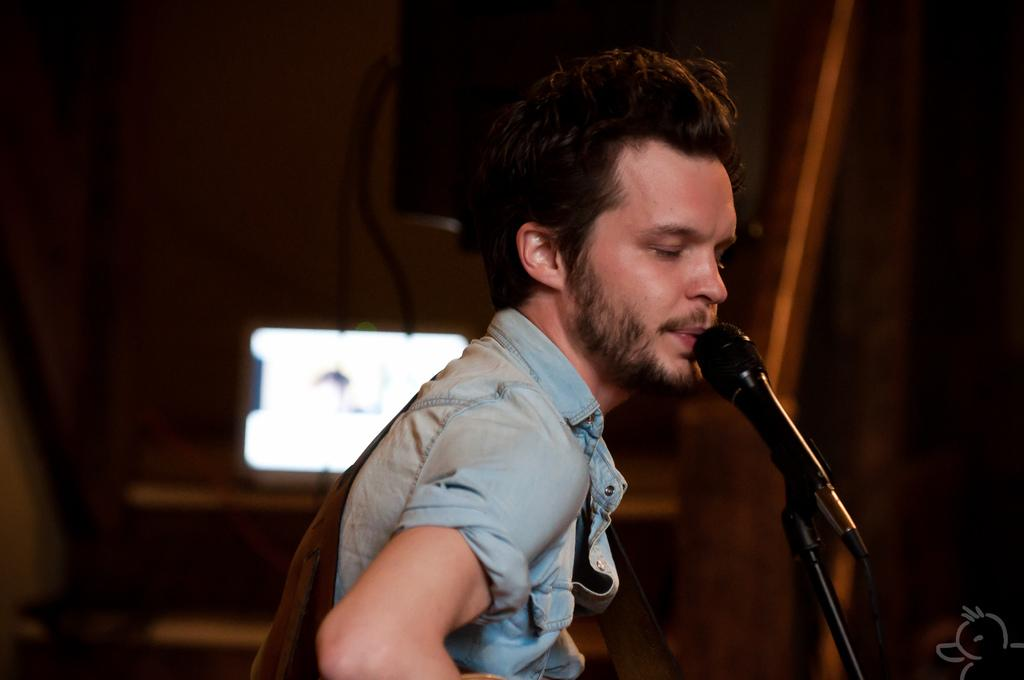What is the main subject in the foreground of the image? There is a person in the foreground of the image. What is the person doing in the image? The person is singing. What can be seen on the right side of the image? There is a microphone and stand on the right side of the image. How would you describe the background of the image? The background of the image is blurred. What color is the object the person is wearing? The person is wearing a brown-colored object. What is the person's monthly income in the image? There is no information about the person's income in the image. Can you tell me if the person's mom is present in the image? There is no information about the person's mom in the image. 